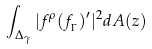<formula> <loc_0><loc_0><loc_500><loc_500>\int _ { \Delta _ { \gamma } } | f ^ { \rho } ( f _ { _ { \Gamma } } ) ^ { \prime } | ^ { 2 } d A ( z )</formula> 